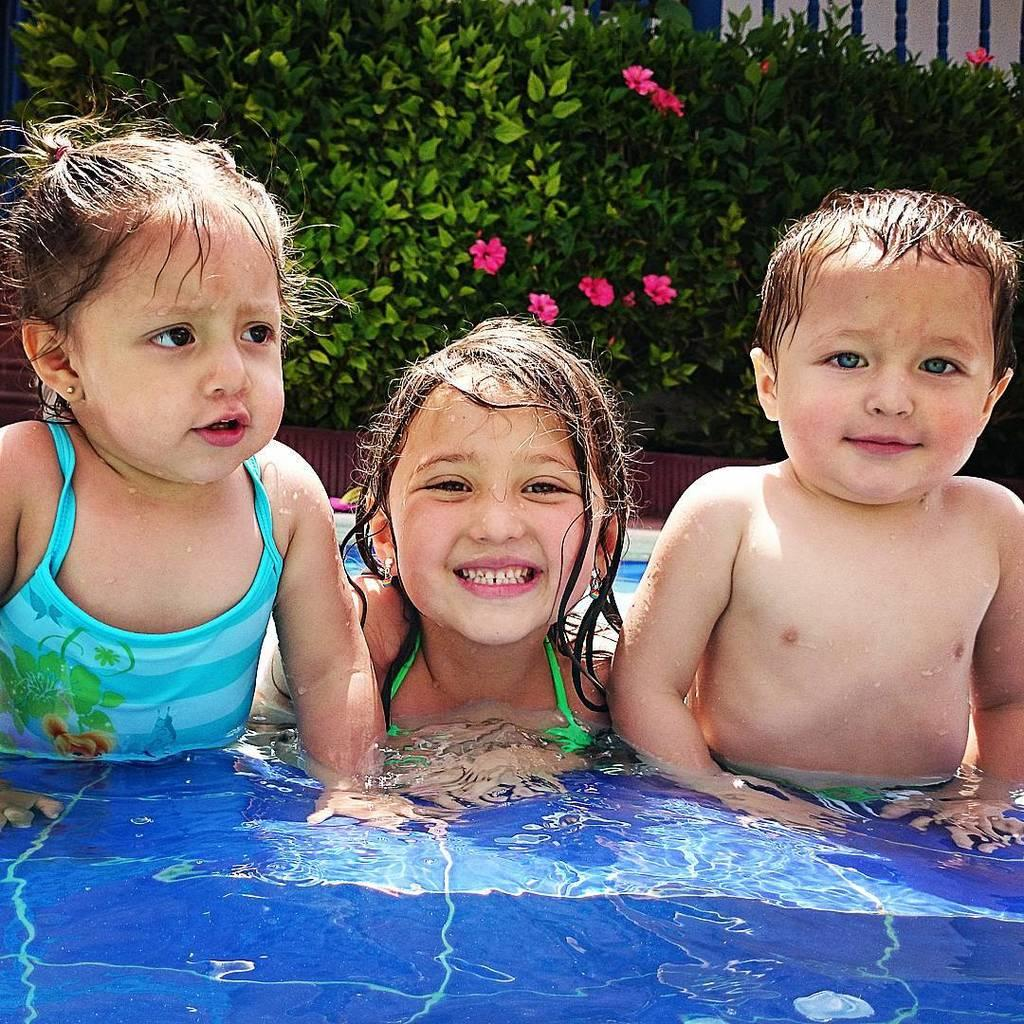How many kids are in the image? There are three kids in the foreground of the image. What are the kids doing in the image? The kids are in the water. What can be seen in the background of the image? There are planets visible in the background of the image, and there is a fence. Can you describe the setting where the kids are located? The image may have been taken near a swimming pool, as the kids are in the water. What type of cable can be seen connecting the planets in the image? There are no cables connecting the planets in the image; they are simply visible in the background. Is the image taken during the night or day? The image does not provide any information about the time of day, so it cannot be determined whether it was taken during the night or day. 